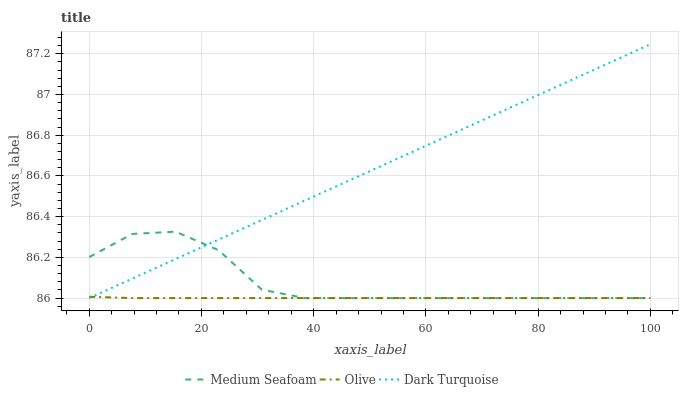Does Olive have the minimum area under the curve?
Answer yes or no. Yes. Does Dark Turquoise have the maximum area under the curve?
Answer yes or no. Yes. Does Medium Seafoam have the minimum area under the curve?
Answer yes or no. No. Does Medium Seafoam have the maximum area under the curve?
Answer yes or no. No. Is Dark Turquoise the smoothest?
Answer yes or no. Yes. Is Medium Seafoam the roughest?
Answer yes or no. Yes. Is Medium Seafoam the smoothest?
Answer yes or no. No. Is Dark Turquoise the roughest?
Answer yes or no. No. Does Dark Turquoise have the highest value?
Answer yes or no. Yes. Does Medium Seafoam have the highest value?
Answer yes or no. No. Does Dark Turquoise intersect Medium Seafoam?
Answer yes or no. Yes. Is Dark Turquoise less than Medium Seafoam?
Answer yes or no. No. Is Dark Turquoise greater than Medium Seafoam?
Answer yes or no. No. 